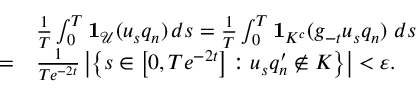<formula> <loc_0><loc_0><loc_500><loc_500>\begin{array} { r l } & { \frac { 1 } { T } \int _ { 0 } ^ { T } 1 _ { \mathcal { U } } ( u _ { s } q _ { n } ) \, d s = \frac { 1 } { T } \int _ { 0 } ^ { T } 1 _ { K ^ { c } } ( g _ { - t } u _ { s } q _ { n } ) \ d s } \\ { = } & { \frac { 1 } { T e ^ { - 2 t } } \left | \left \{ s \in \left [ 0 , T e ^ { - 2 t } \right ] \colon u _ { s } q _ { n } ^ { \prime } \notin K \right \} \right | < \varepsilon . } \end{array}</formula> 